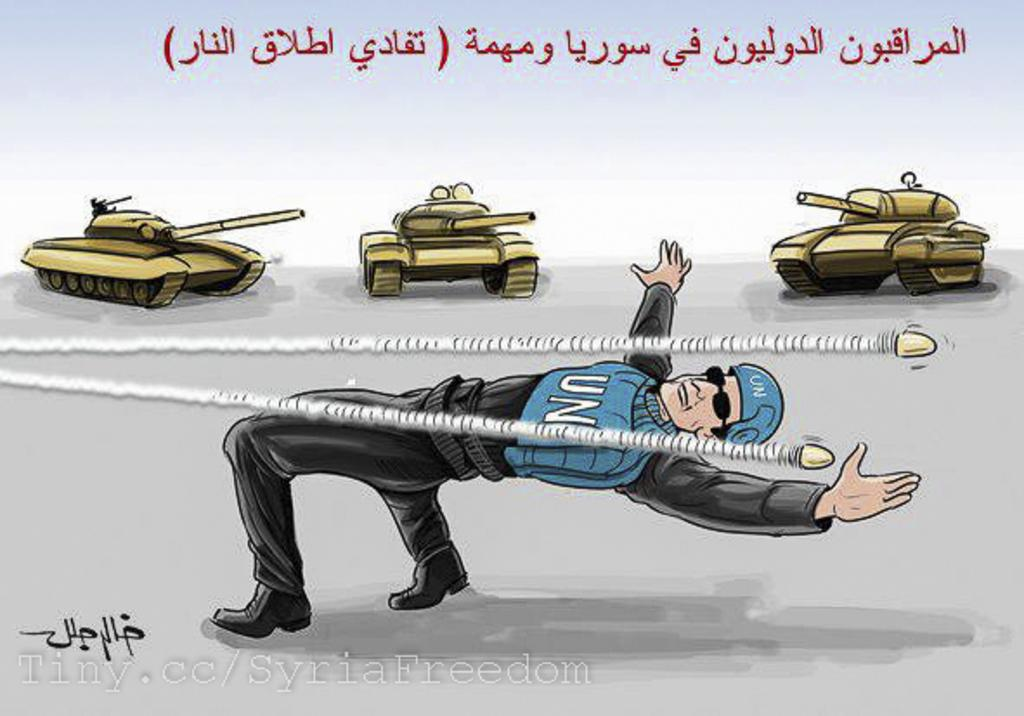What type of image is depicted in the center of the image? There is a photo of a cartoon man in the image. What military vehicles are present in the image? There are two military tankers in the image. What language is used for the text in the image? The text in the image is written in Arabic. What type of neck accessory is the cartoon man wearing in the image? There is no neck accessory visible on the cartoon man in the image. What authority figure is depicted in the image? There is no authority figure depicted in the image; it features a cartoon man, military tankers, and Arabic text. 